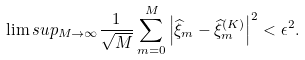Convert formula to latex. <formula><loc_0><loc_0><loc_500><loc_500>\lim s u p _ { M \to \infty } \frac { 1 } { \sqrt { M } } \sum _ { m = 0 } ^ { M } \left | \widehat { \xi } _ { m } - \widehat { \xi } ^ { ( K ) } _ { m } \right | ^ { 2 } < \epsilon ^ { 2 } .</formula> 